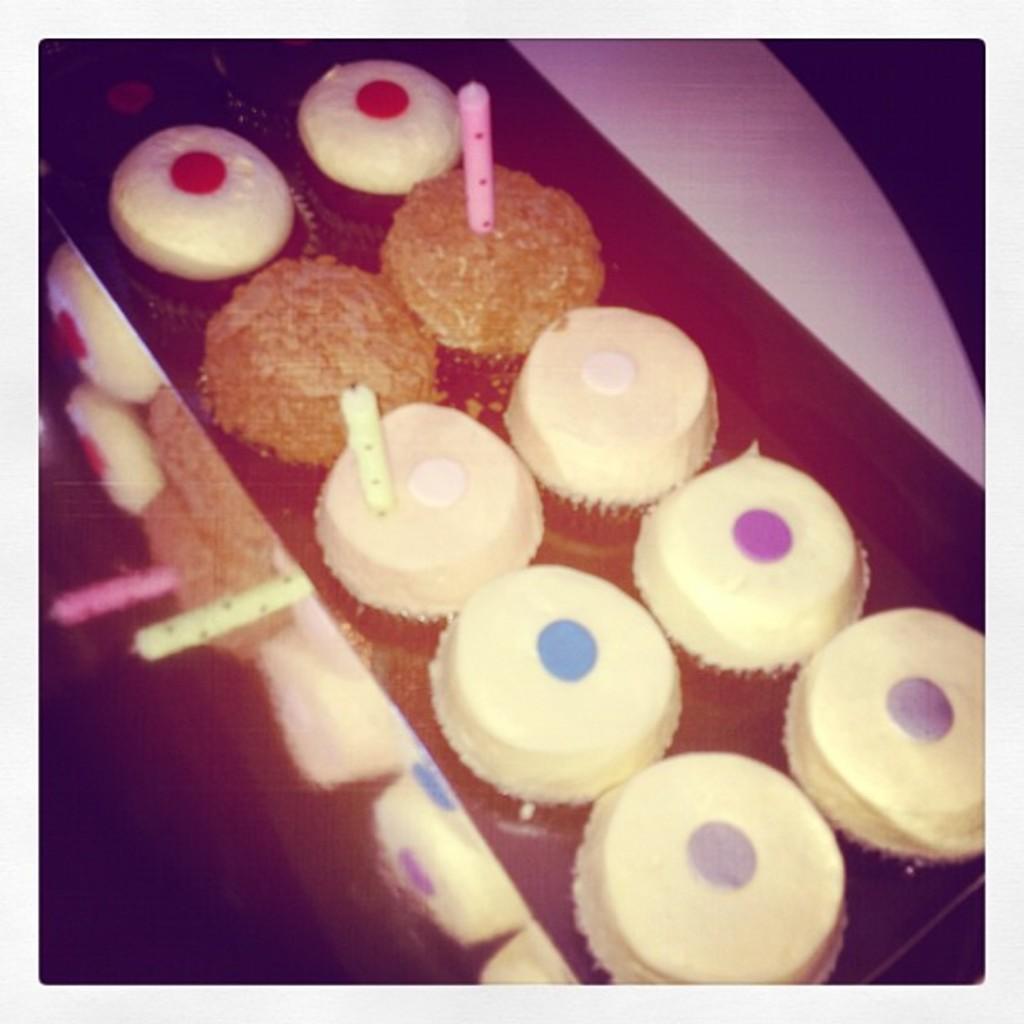Could you give a brief overview of what you see in this image? In this image there is a table. We can see the colorful food items. 